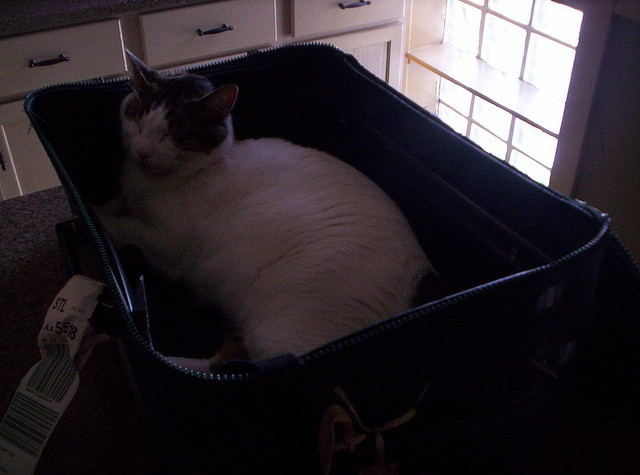Describe the objects in this image and their specific colors. I can see suitcase in black and purple tones and cat in black and purple tones in this image. 